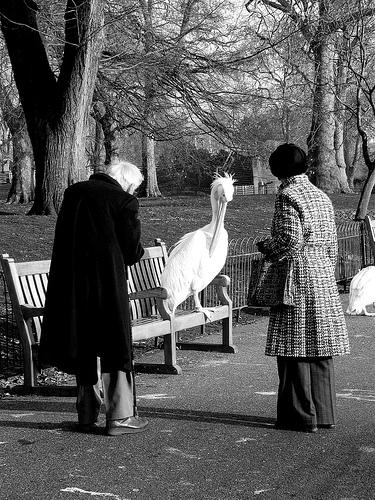Question: what separates the pavement from the grass?
Choices:
A. A fence.
B. A curb.
C. A wall.
D. A sign.
Answer with the letter. Answer: A Question: what is the animal in the picture?
Choices:
A. A horse.
B. A fish.
C. A mouse.
D. A stork.
Answer with the letter. Answer: D Question: what is the stork standing on?
Choices:
A. A lamp post.
B. A bench.
C. A mailbox.
D. A table.
Answer with the letter. Answer: B Question: how many men are in the picture?
Choices:
A. 2.
B. 3.
C. 1.
D. 4.
Answer with the letter. Answer: C Question: who carries the purse?
Choices:
A. The man.
B. The dog.
C. The woman.
D. The baby.
Answer with the letter. Answer: C Question: when was the photo taken?
Choices:
A. After the wedding.
B. Before graduation.
C. At dinner.
D. Daytime.
Answer with the letter. Answer: D Question: where is the bird on the left?
Choices:
A. On the bench.
B. Birdhouse.
C. Roof.
D. Powerline.
Answer with the letter. Answer: A Question: what type of picture is shown?
Choices:
A. Black and white.
B. Doctored.
C. Color.
D. Blurry.
Answer with the letter. Answer: A 